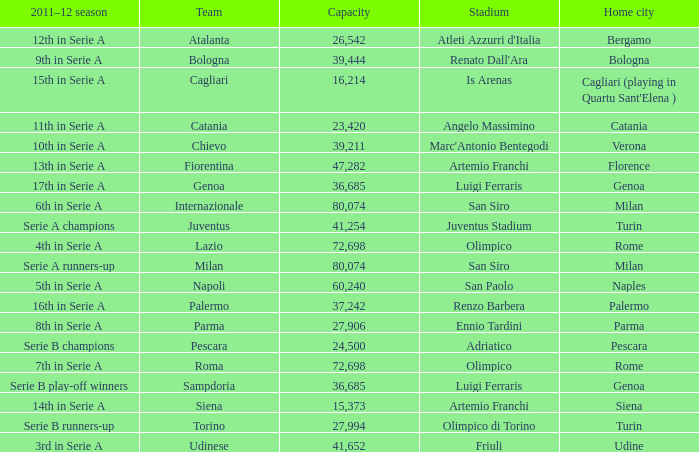What is the home city for angelo massimino stadium? Catania. 